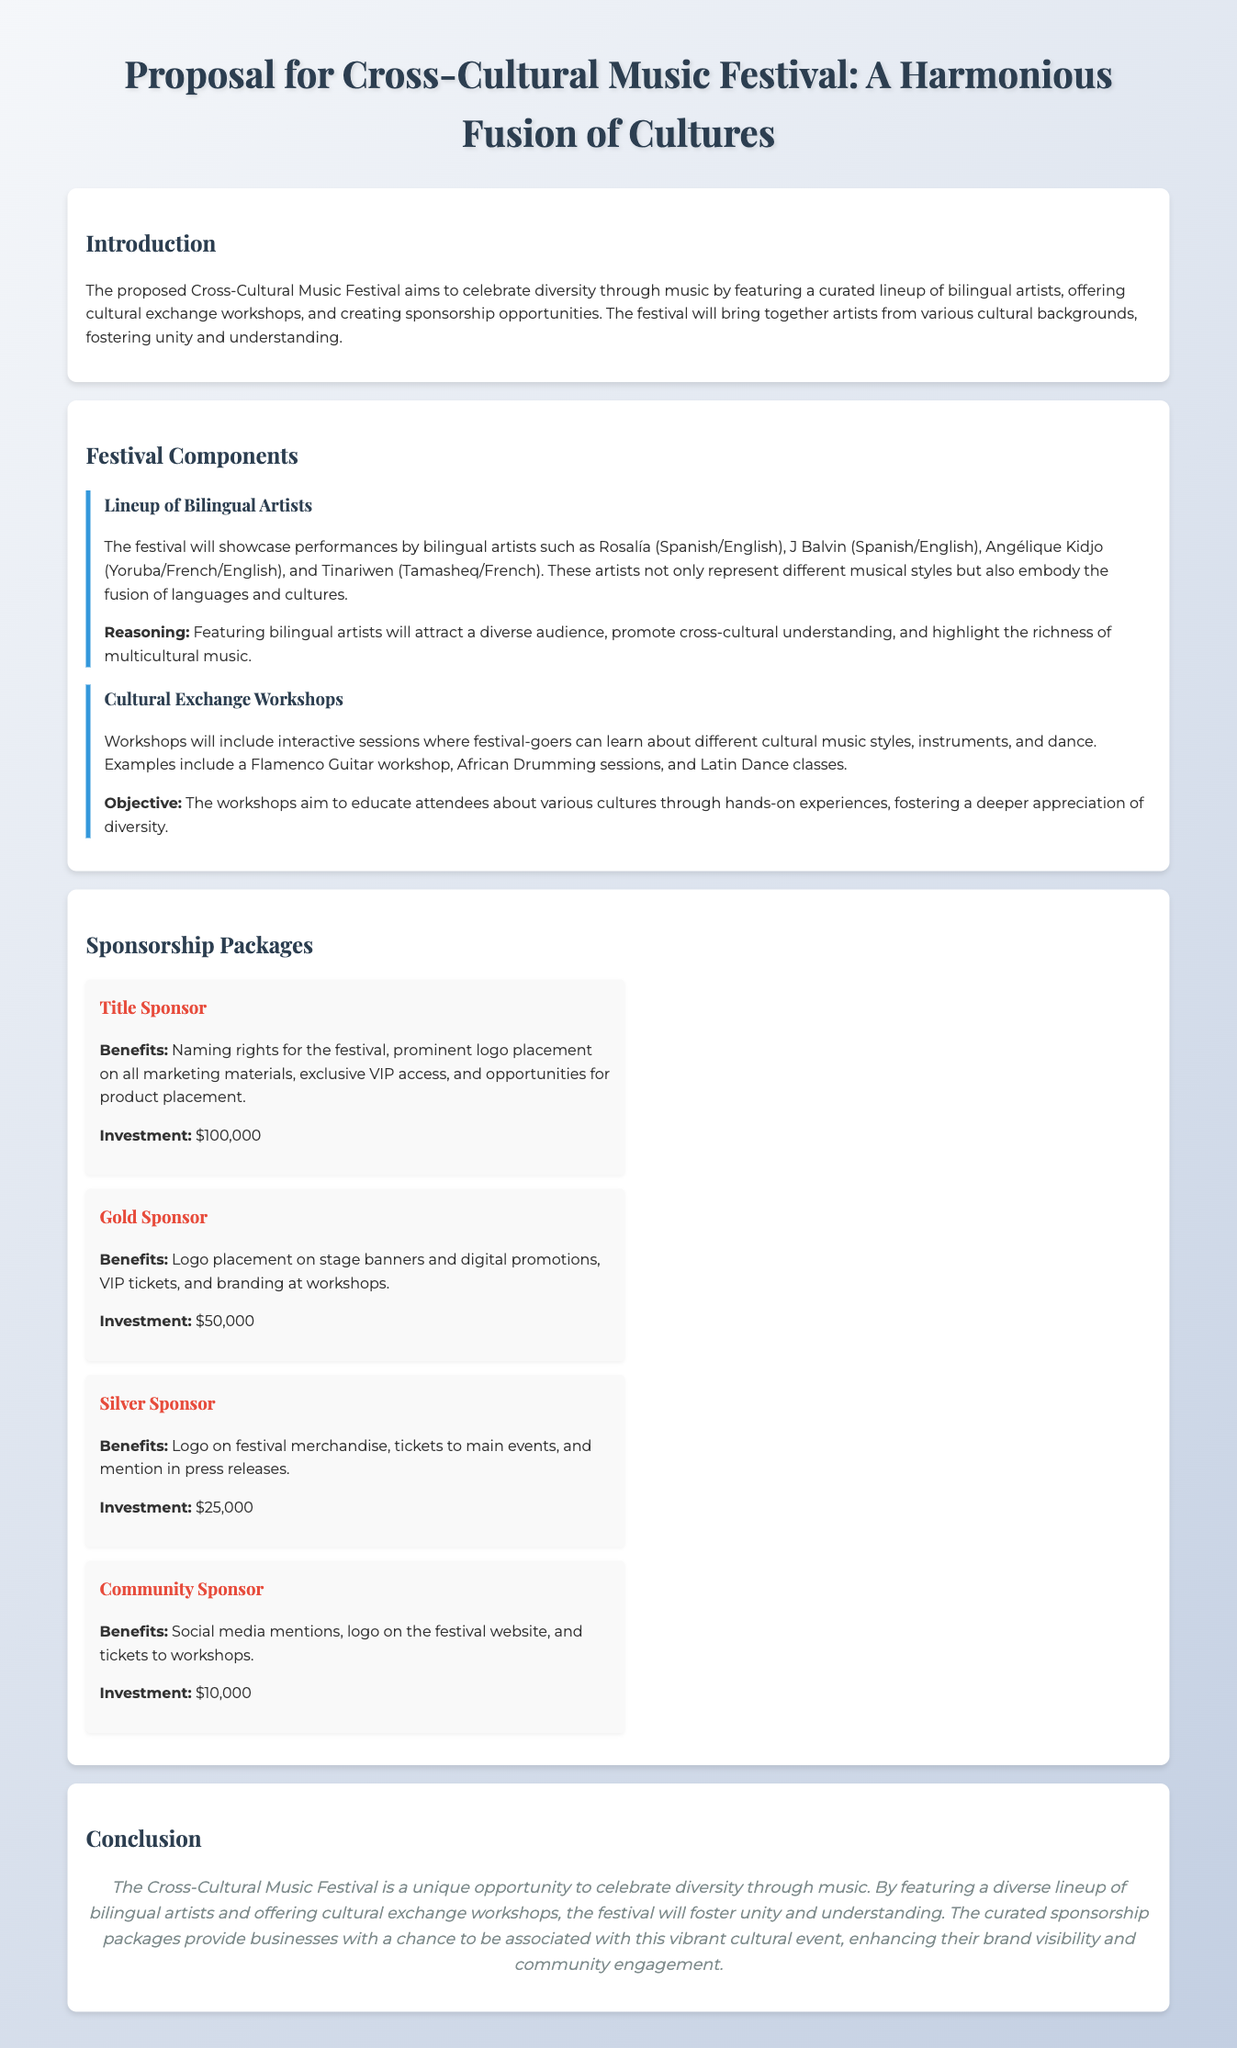what is the title of the proposal? The title of the proposal is found in the first heading of the document.
Answer: Proposal for Cross-Cultural Music Festival: A Harmonious Fusion of Cultures how many bilingual artists are mentioned in the lineup? The document specifies the names of several bilingual artists in the lineup section.
Answer: Four what is one of the objectives of the cultural exchange workshops? The objective of the workshops is stated in the description of that section.
Answer: Educate attendees about various cultures how much is the investment for the Title Sponsor? The investment amount for the Title Sponsor is listed under the sponsorship packages section.
Answer: $100,000 which artist represents Yoruba/French/English music? The document contains the names of artists along with their represented languages.
Answer: Angélique Kidjo what type of workshop is mentioned alongside African Drumming? The document lists the types of workshops available with specific examples.
Answer: Latin Dance classes what is the color of the Title Sponsor benefits section? The benefits section for Title Sponsor is indicated by its distinctive formatting features in the proposal.
Answer: Red what is the main theme of the Cross-Cultural Music Festival? The main theme is summarized in the introduction section and represents the festival's focus.
Answer: Diversity through music 